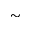Convert formula to latex. <formula><loc_0><loc_0><loc_500><loc_500>\sim</formula> 